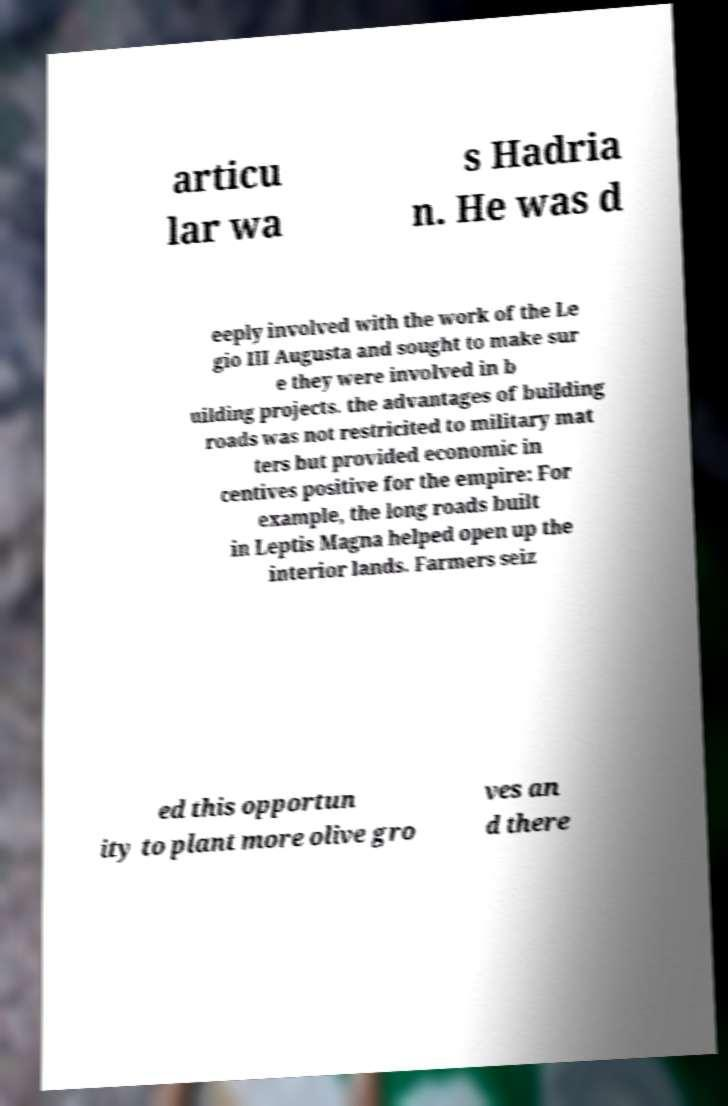Could you extract and type out the text from this image? articu lar wa s Hadria n. He was d eeply involved with the work of the Le gio III Augusta and sought to make sur e they were involved in b uilding projects. the advantages of building roads was not restricited to military mat ters but provided economic in centives positive for the empire: For example, the long roads built in Leptis Magna helped open up the interior lands. Farmers seiz ed this opportun ity to plant more olive gro ves an d there 